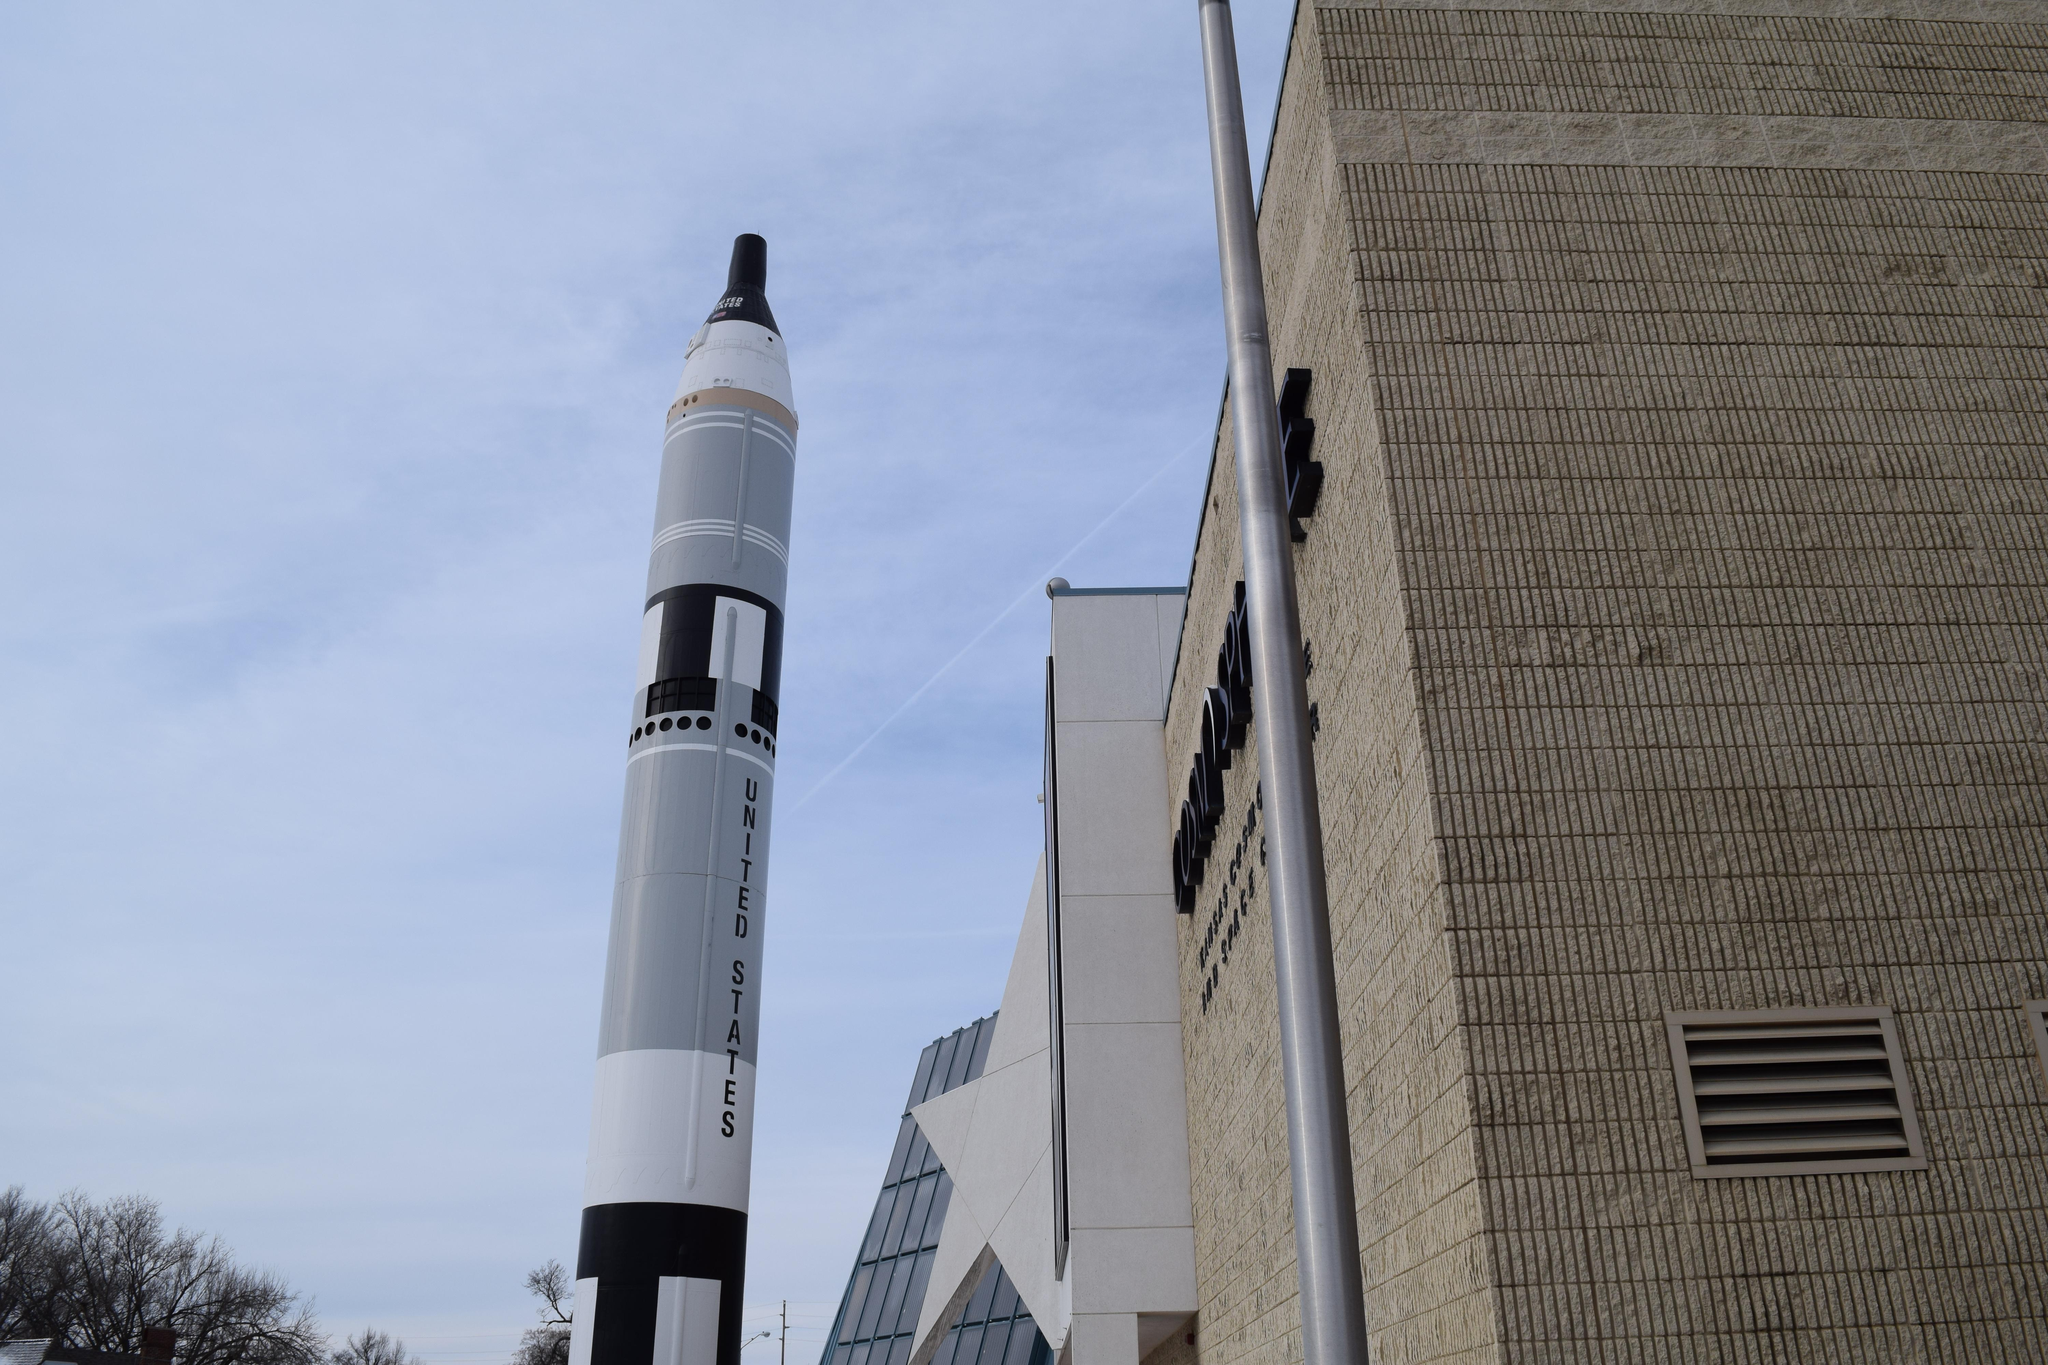What is the main subject of the image? There is a rocket in the image. What else can be seen in the image besides the rocket? There are buildings, trees, and the sky visible in the image. Can you tell me where the friend is saying good-bye to the oven in the image? There is no friend or oven present in the image. 